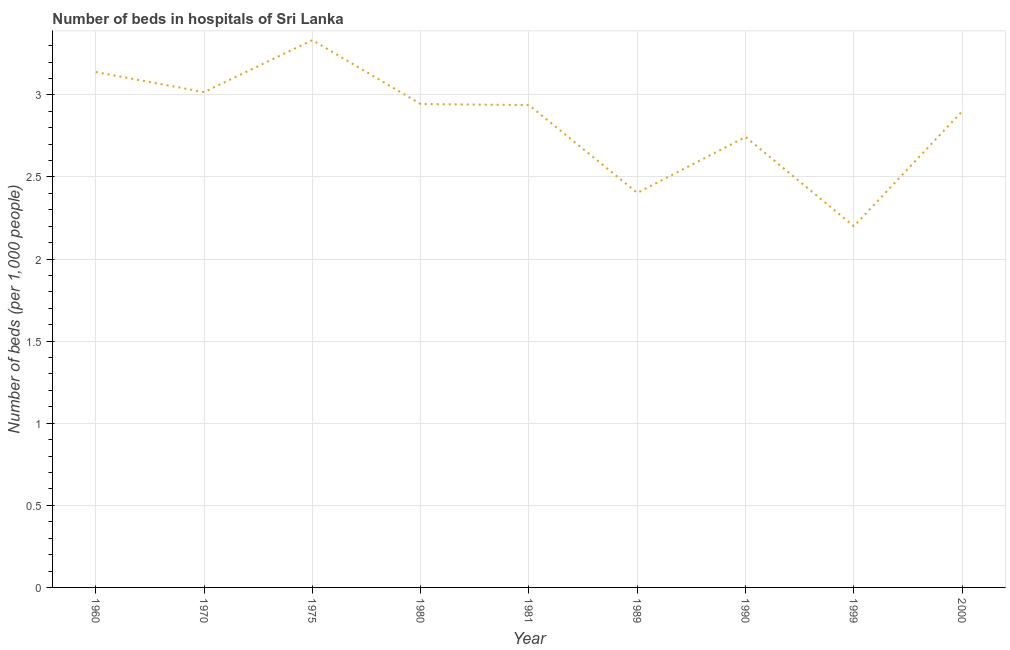What is the number of hospital beds in 1980?
Your answer should be very brief. 2.94. Across all years, what is the maximum number of hospital beds?
Offer a very short reply. 3.33. Across all years, what is the minimum number of hospital beds?
Offer a very short reply. 2.2. In which year was the number of hospital beds maximum?
Provide a short and direct response. 1975. In which year was the number of hospital beds minimum?
Your answer should be very brief. 1999. What is the sum of the number of hospital beds?
Your answer should be compact. 25.62. What is the difference between the number of hospital beds in 1975 and 1980?
Provide a succinct answer. 0.39. What is the average number of hospital beds per year?
Offer a very short reply. 2.85. What is the median number of hospital beds?
Offer a terse response. 2.94. In how many years, is the number of hospital beds greater than 2.6 %?
Keep it short and to the point. 7. Do a majority of the years between 1999 and 1981 (inclusive) have number of hospital beds greater than 1.5 %?
Ensure brevity in your answer.  Yes. What is the ratio of the number of hospital beds in 1980 to that in 1990?
Your response must be concise. 1.07. What is the difference between the highest and the second highest number of hospital beds?
Offer a very short reply. 0.19. What is the difference between the highest and the lowest number of hospital beds?
Provide a succinct answer. 1.13. In how many years, is the number of hospital beds greater than the average number of hospital beds taken over all years?
Ensure brevity in your answer.  6. Does the number of hospital beds monotonically increase over the years?
Give a very brief answer. No. How many lines are there?
Offer a very short reply. 1. How many years are there in the graph?
Offer a terse response. 9. What is the difference between two consecutive major ticks on the Y-axis?
Offer a very short reply. 0.5. What is the title of the graph?
Give a very brief answer. Number of beds in hospitals of Sri Lanka. What is the label or title of the X-axis?
Ensure brevity in your answer.  Year. What is the label or title of the Y-axis?
Give a very brief answer. Number of beds (per 1,0 people). What is the Number of beds (per 1,000 people) in 1960?
Make the answer very short. 3.14. What is the Number of beds (per 1,000 people) in 1970?
Your answer should be compact. 3.02. What is the Number of beds (per 1,000 people) of 1975?
Your response must be concise. 3.33. What is the Number of beds (per 1,000 people) in 1980?
Provide a succinct answer. 2.94. What is the Number of beds (per 1,000 people) in 1981?
Offer a very short reply. 2.94. What is the Number of beds (per 1,000 people) of 1989?
Your answer should be very brief. 2.4. What is the Number of beds (per 1,000 people) of 1990?
Provide a short and direct response. 2.74. What is the Number of beds (per 1,000 people) of 1999?
Your response must be concise. 2.2. What is the difference between the Number of beds (per 1,000 people) in 1960 and 1970?
Offer a very short reply. 0.12. What is the difference between the Number of beds (per 1,000 people) in 1960 and 1975?
Make the answer very short. -0.19. What is the difference between the Number of beds (per 1,000 people) in 1960 and 1980?
Offer a terse response. 0.19. What is the difference between the Number of beds (per 1,000 people) in 1960 and 1981?
Provide a short and direct response. 0.2. What is the difference between the Number of beds (per 1,000 people) in 1960 and 1989?
Provide a short and direct response. 0.74. What is the difference between the Number of beds (per 1,000 people) in 1960 and 1990?
Provide a short and direct response. 0.4. What is the difference between the Number of beds (per 1,000 people) in 1960 and 1999?
Your answer should be very brief. 0.94. What is the difference between the Number of beds (per 1,000 people) in 1960 and 2000?
Your answer should be very brief. 0.24. What is the difference between the Number of beds (per 1,000 people) in 1970 and 1975?
Your answer should be compact. -0.32. What is the difference between the Number of beds (per 1,000 people) in 1970 and 1980?
Keep it short and to the point. 0.07. What is the difference between the Number of beds (per 1,000 people) in 1970 and 1981?
Your response must be concise. 0.08. What is the difference between the Number of beds (per 1,000 people) in 1970 and 1989?
Give a very brief answer. 0.61. What is the difference between the Number of beds (per 1,000 people) in 1970 and 1990?
Keep it short and to the point. 0.27. What is the difference between the Number of beds (per 1,000 people) in 1970 and 1999?
Make the answer very short. 0.82. What is the difference between the Number of beds (per 1,000 people) in 1970 and 2000?
Make the answer very short. 0.12. What is the difference between the Number of beds (per 1,000 people) in 1975 and 1980?
Make the answer very short. 0.39. What is the difference between the Number of beds (per 1,000 people) in 1975 and 1981?
Offer a very short reply. 0.4. What is the difference between the Number of beds (per 1,000 people) in 1975 and 1989?
Ensure brevity in your answer.  0.93. What is the difference between the Number of beds (per 1,000 people) in 1975 and 1990?
Offer a very short reply. 0.59. What is the difference between the Number of beds (per 1,000 people) in 1975 and 1999?
Offer a very short reply. 1.13. What is the difference between the Number of beds (per 1,000 people) in 1975 and 2000?
Provide a succinct answer. 0.43. What is the difference between the Number of beds (per 1,000 people) in 1980 and 1981?
Offer a very short reply. 0.01. What is the difference between the Number of beds (per 1,000 people) in 1980 and 1989?
Offer a very short reply. 0.54. What is the difference between the Number of beds (per 1,000 people) in 1980 and 1990?
Offer a very short reply. 0.2. What is the difference between the Number of beds (per 1,000 people) in 1980 and 1999?
Your response must be concise. 0.74. What is the difference between the Number of beds (per 1,000 people) in 1980 and 2000?
Your response must be concise. 0.04. What is the difference between the Number of beds (per 1,000 people) in 1981 and 1989?
Your answer should be very brief. 0.53. What is the difference between the Number of beds (per 1,000 people) in 1981 and 1990?
Provide a succinct answer. 0.19. What is the difference between the Number of beds (per 1,000 people) in 1981 and 1999?
Your answer should be compact. 0.74. What is the difference between the Number of beds (per 1,000 people) in 1981 and 2000?
Keep it short and to the point. 0.04. What is the difference between the Number of beds (per 1,000 people) in 1989 and 1990?
Provide a short and direct response. -0.34. What is the difference between the Number of beds (per 1,000 people) in 1989 and 1999?
Ensure brevity in your answer.  0.2. What is the difference between the Number of beds (per 1,000 people) in 1989 and 2000?
Offer a terse response. -0.5. What is the difference between the Number of beds (per 1,000 people) in 1990 and 1999?
Keep it short and to the point. 0.54. What is the difference between the Number of beds (per 1,000 people) in 1990 and 2000?
Your response must be concise. -0.16. What is the difference between the Number of beds (per 1,000 people) in 1999 and 2000?
Offer a very short reply. -0.7. What is the ratio of the Number of beds (per 1,000 people) in 1960 to that in 1975?
Make the answer very short. 0.94. What is the ratio of the Number of beds (per 1,000 people) in 1960 to that in 1980?
Make the answer very short. 1.07. What is the ratio of the Number of beds (per 1,000 people) in 1960 to that in 1981?
Your answer should be very brief. 1.07. What is the ratio of the Number of beds (per 1,000 people) in 1960 to that in 1989?
Provide a succinct answer. 1.31. What is the ratio of the Number of beds (per 1,000 people) in 1960 to that in 1990?
Your answer should be compact. 1.14. What is the ratio of the Number of beds (per 1,000 people) in 1960 to that in 1999?
Offer a very short reply. 1.43. What is the ratio of the Number of beds (per 1,000 people) in 1960 to that in 2000?
Your answer should be compact. 1.08. What is the ratio of the Number of beds (per 1,000 people) in 1970 to that in 1975?
Offer a very short reply. 0.91. What is the ratio of the Number of beds (per 1,000 people) in 1970 to that in 1981?
Provide a short and direct response. 1.03. What is the ratio of the Number of beds (per 1,000 people) in 1970 to that in 1989?
Ensure brevity in your answer.  1.25. What is the ratio of the Number of beds (per 1,000 people) in 1970 to that in 1999?
Your response must be concise. 1.37. What is the ratio of the Number of beds (per 1,000 people) in 1975 to that in 1980?
Keep it short and to the point. 1.13. What is the ratio of the Number of beds (per 1,000 people) in 1975 to that in 1981?
Offer a very short reply. 1.14. What is the ratio of the Number of beds (per 1,000 people) in 1975 to that in 1989?
Provide a short and direct response. 1.39. What is the ratio of the Number of beds (per 1,000 people) in 1975 to that in 1990?
Keep it short and to the point. 1.22. What is the ratio of the Number of beds (per 1,000 people) in 1975 to that in 1999?
Provide a succinct answer. 1.51. What is the ratio of the Number of beds (per 1,000 people) in 1975 to that in 2000?
Offer a very short reply. 1.15. What is the ratio of the Number of beds (per 1,000 people) in 1980 to that in 1989?
Your response must be concise. 1.23. What is the ratio of the Number of beds (per 1,000 people) in 1980 to that in 1990?
Your answer should be very brief. 1.07. What is the ratio of the Number of beds (per 1,000 people) in 1980 to that in 1999?
Offer a terse response. 1.34. What is the ratio of the Number of beds (per 1,000 people) in 1981 to that in 1989?
Offer a very short reply. 1.22. What is the ratio of the Number of beds (per 1,000 people) in 1981 to that in 1990?
Give a very brief answer. 1.07. What is the ratio of the Number of beds (per 1,000 people) in 1981 to that in 1999?
Your answer should be very brief. 1.33. What is the ratio of the Number of beds (per 1,000 people) in 1981 to that in 2000?
Give a very brief answer. 1.01. What is the ratio of the Number of beds (per 1,000 people) in 1989 to that in 1990?
Ensure brevity in your answer.  0.88. What is the ratio of the Number of beds (per 1,000 people) in 1989 to that in 1999?
Ensure brevity in your answer.  1.09. What is the ratio of the Number of beds (per 1,000 people) in 1989 to that in 2000?
Offer a terse response. 0.83. What is the ratio of the Number of beds (per 1,000 people) in 1990 to that in 1999?
Your answer should be compact. 1.25. What is the ratio of the Number of beds (per 1,000 people) in 1990 to that in 2000?
Provide a short and direct response. 0.95. What is the ratio of the Number of beds (per 1,000 people) in 1999 to that in 2000?
Offer a terse response. 0.76. 